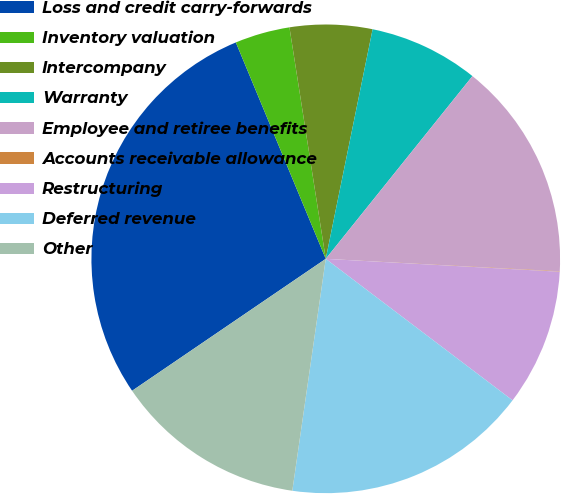<chart> <loc_0><loc_0><loc_500><loc_500><pie_chart><fcel>Loss and credit carry-forwards<fcel>Inventory valuation<fcel>Intercompany<fcel>Warranty<fcel>Employee and retiree benefits<fcel>Accounts receivable allowance<fcel>Restructuring<fcel>Deferred revenue<fcel>Other<nl><fcel>28.25%<fcel>3.79%<fcel>5.68%<fcel>7.56%<fcel>15.08%<fcel>0.03%<fcel>9.44%<fcel>16.96%<fcel>13.2%<nl></chart> 